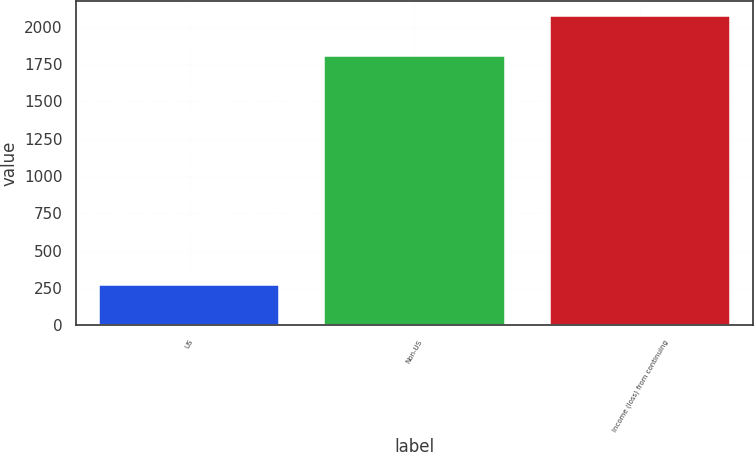Convert chart. <chart><loc_0><loc_0><loc_500><loc_500><bar_chart><fcel>US<fcel>Non-US<fcel>Income (loss) from continuing<nl><fcel>271<fcel>1801<fcel>2072<nl></chart> 